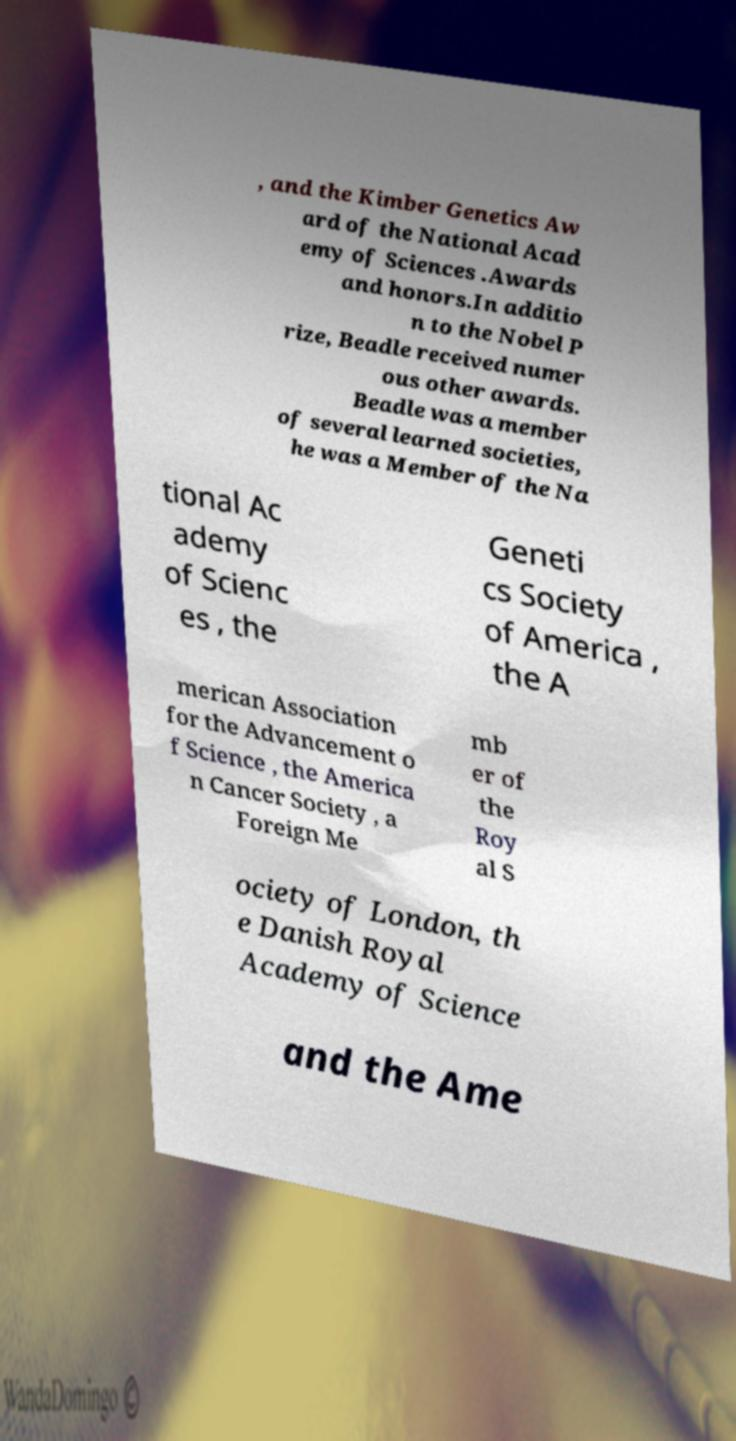There's text embedded in this image that I need extracted. Can you transcribe it verbatim? , and the Kimber Genetics Aw ard of the National Acad emy of Sciences .Awards and honors.In additio n to the Nobel P rize, Beadle received numer ous other awards. Beadle was a member of several learned societies, he was a Member of the Na tional Ac ademy of Scienc es , the Geneti cs Society of America , the A merican Association for the Advancement o f Science , the America n Cancer Society , a Foreign Me mb er of the Roy al S ociety of London, th e Danish Royal Academy of Science and the Ame 